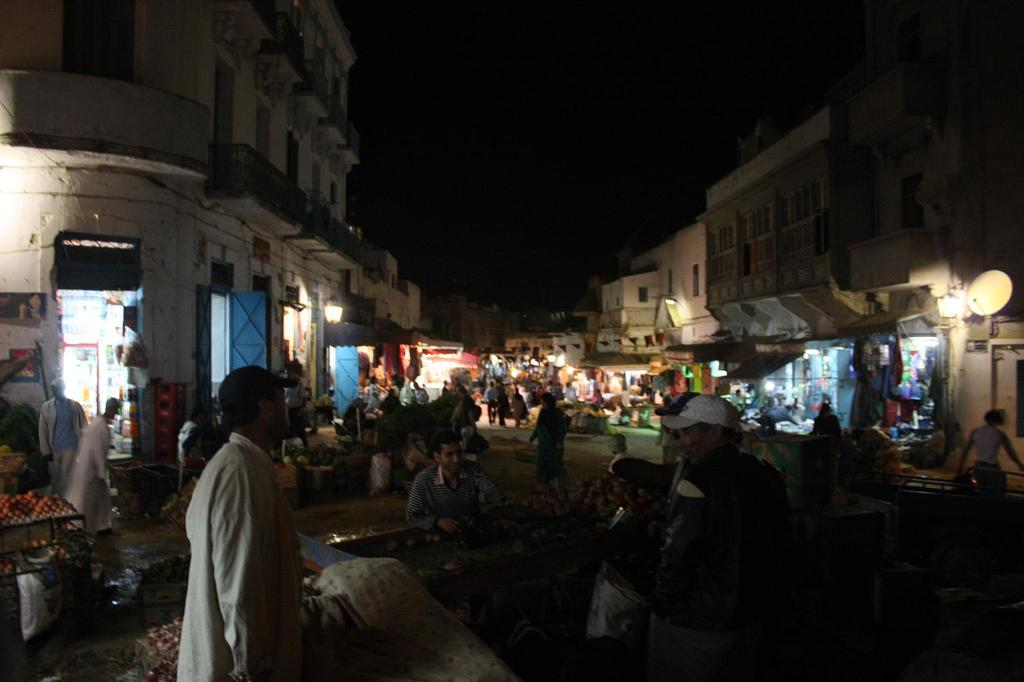What type of location is shown in the image? The image depicts a market. How many people can be seen in the image? There are many people in the image. What are some of the activities taking place in the market? Some people are selling vegetables. What can be seen on the sides of the market? There are buildings with lights on the sides of the market. How would you describe the lighting conditions in the image? The background of the image is dark. What type of design is featured on the zebra in the image? There is no zebra present in the image; it depicts a market with people selling vegetables. 